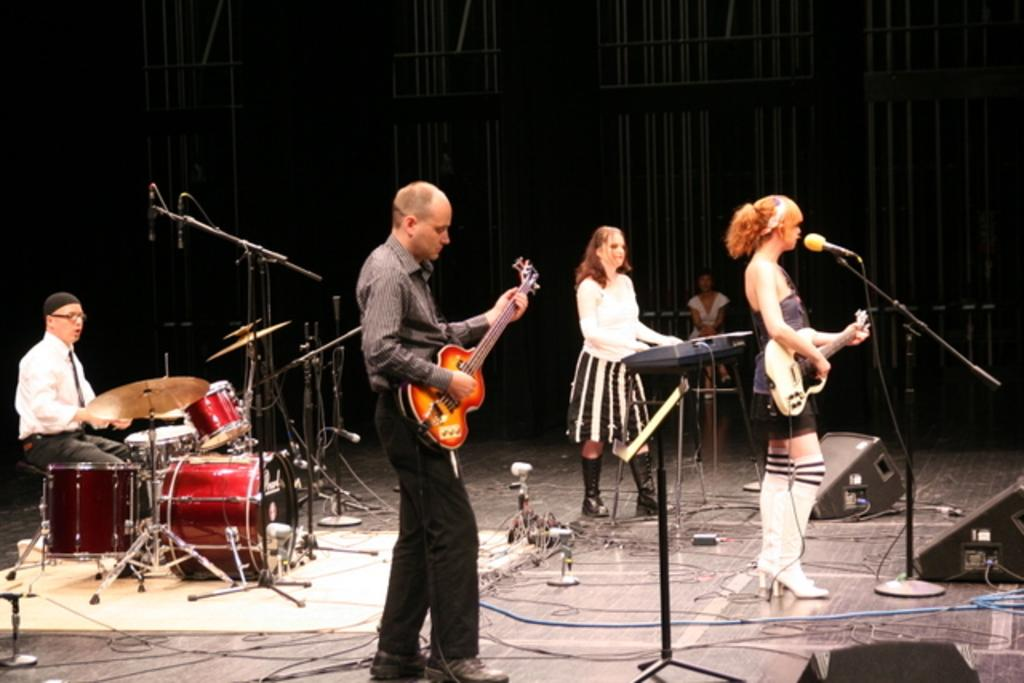How many people are in the image? There are 4 people in the image. Can you describe the gender of the people in the image? There are 2 men and 3 women in the image. What are the people in the image doing? The 4 people are performing. What are they using to accompany their performance? They are playing musical instruments. What device is present to amplify their voices? There is a microphone in the image. What type of marble is being used as a stage for the performance in the image? There is no marble present in the image, nor is there any indication of a stage. 